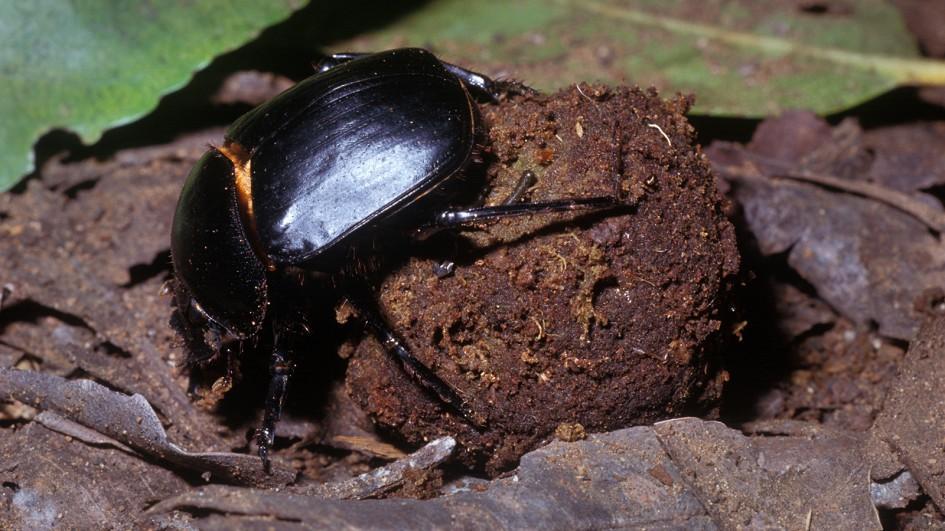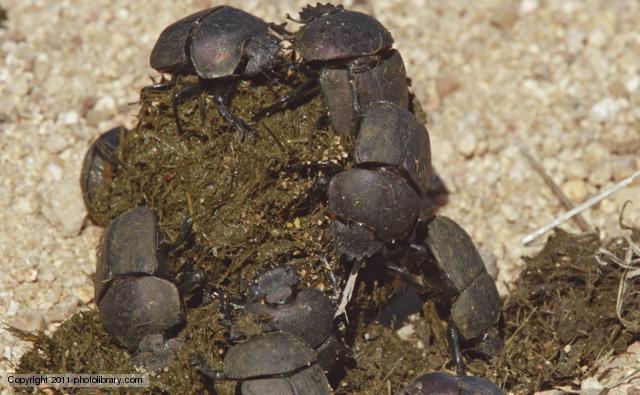The first image is the image on the left, the second image is the image on the right. Examine the images to the left and right. Is the description "An image shows exactly two black beetles by one dung ball." accurate? Answer yes or no. No. 